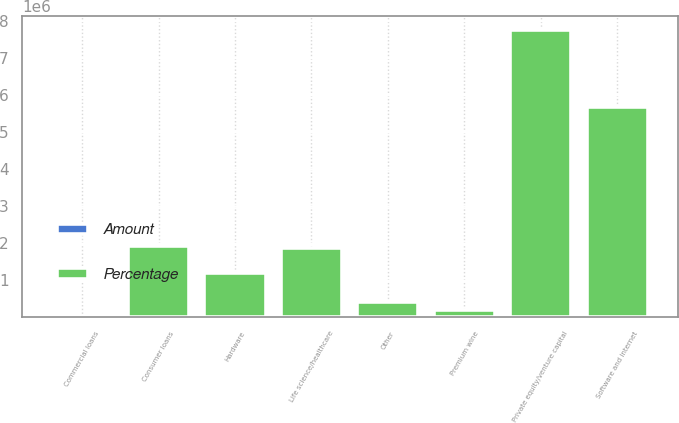Convert chart. <chart><loc_0><loc_0><loc_500><loc_500><stacked_bar_chart><ecel><fcel>Software and internet<fcel>Hardware<fcel>Private equity/venture capital<fcel>Life science/healthcare<fcel>Premium wine<fcel>Other<fcel>Commercial loans<fcel>Consumer loans<nl><fcel>Percentage<fcel>5.66858e+06<fcel>1.18911e+06<fcel>7.74791e+06<fcel>1.86668e+06<fcel>201634<fcel>396458<fcel>85.2<fcel>1.92562e+06<nl><fcel>Amount<fcel>28.3<fcel>5.9<fcel>38.7<fcel>9.3<fcel>1<fcel>2<fcel>85.2<fcel>9.6<nl></chart> 